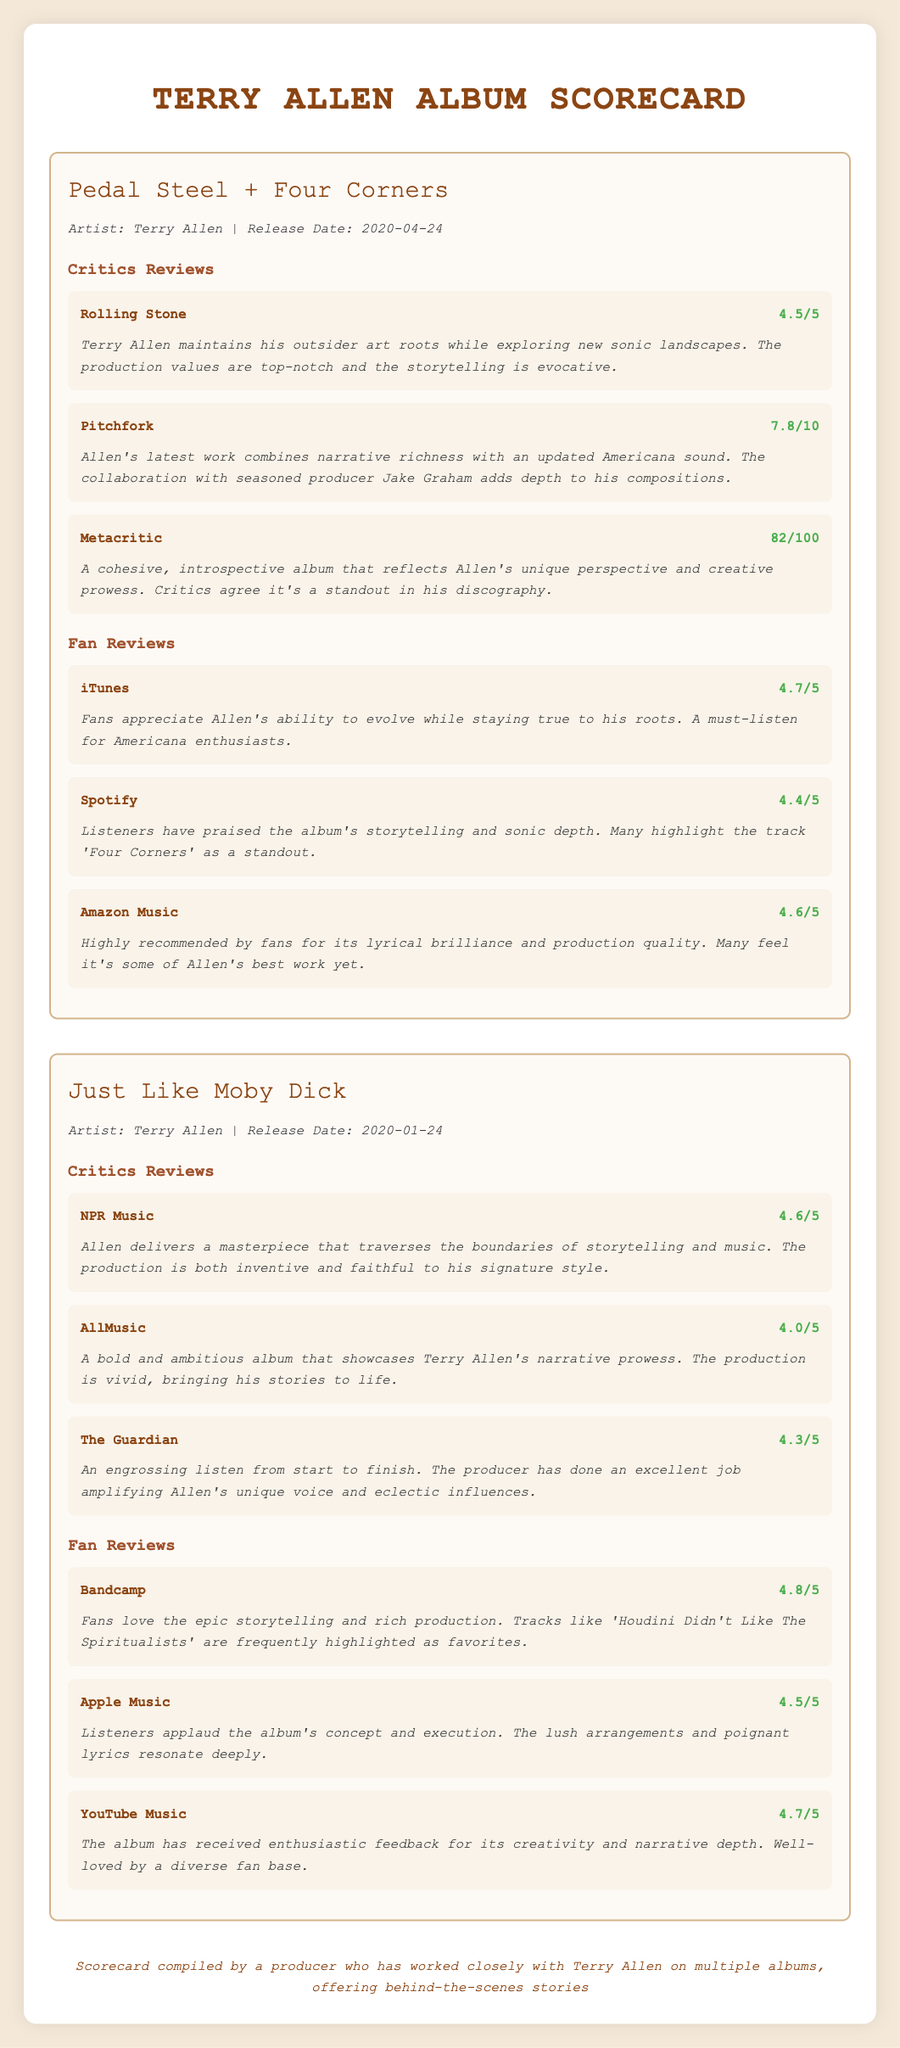What is the title of the first album? The first album listed in the document is "Pedal Steel + Four Corners."
Answer: Pedal Steel + Four Corners What is the release date of "Just Like Moby Dick"? The album "Just Like Moby Dick" was released on January 24, 2020.
Answer: 2020-01-24 What is the highest critic score for "Pedal Steel + Four Corners"? The highest score among critics for "Pedal Steel + Four Corners" is from Rolling Stone, which is 4.5 out of 5.
Answer: 4.5/5 Which fan platform gave "Just Like Moby Dick" the highest rating? Bandcamp awarded "Just Like Moby Dick" a score of 4.8 out of 5, the highest rating from fans.
Answer: 4.8/5 What theme is frequently mentioned in fan feedback for "Pedal Steel + Four Corners"? Fans appreciate Allen's ability to evolve while staying true to his roots.
Answer: Evolve while staying true to roots How many reviews are there in total for "Just Like Moby Dick"? There are three critic reviews and three fan reviews for "Just Like Moby Dick," totaling six reviews.
Answer: 6 What type of scoring system is primarily used in the document? The scoring system used for reviews primarily includes scores out of 5 or 10.
Answer: 5 or 10 Which reviewer gave "Pedal Steel + Four Corners" a score of 7.8? The score of 7.8 out of 10 for "Pedal Steel + Four Corners" was given by Pitchfork.
Answer: Pitchfork 